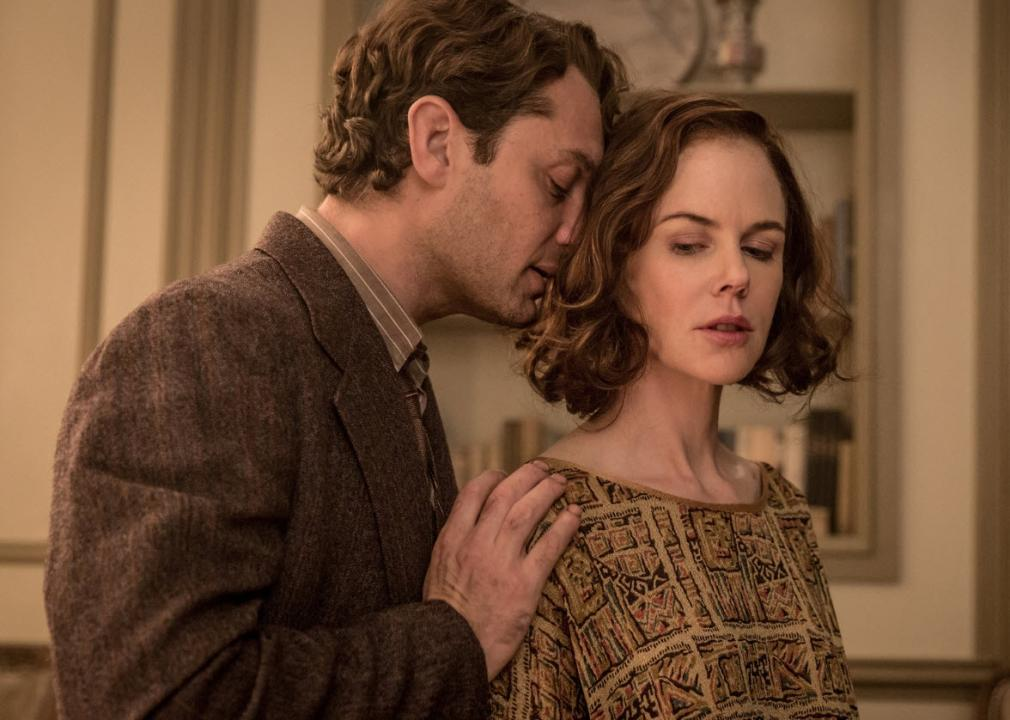What is this photo about? This image captures a moment from the movie 'Genius', showing a scene between the characters played by Jude Law and Nicole Kidman. Jude Law, in period attire with a tweed jacket, intimately leans in towards Nicole Kidman, who is dressed in an elaborately patterned dress, whispering into her ear or perhaps stealing a kiss. The setting and their attire reflect the era the film is set in, likely the early 20th century. This moment could indicate a pivotal or emotional turn in their relationship, highlighting complexities and underlying themes of intimacy, creativity, and the profound impacts they have on each other's lives as depicted in the movie. 